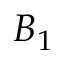Convert formula to latex. <formula><loc_0><loc_0><loc_500><loc_500>B _ { 1 }</formula> 